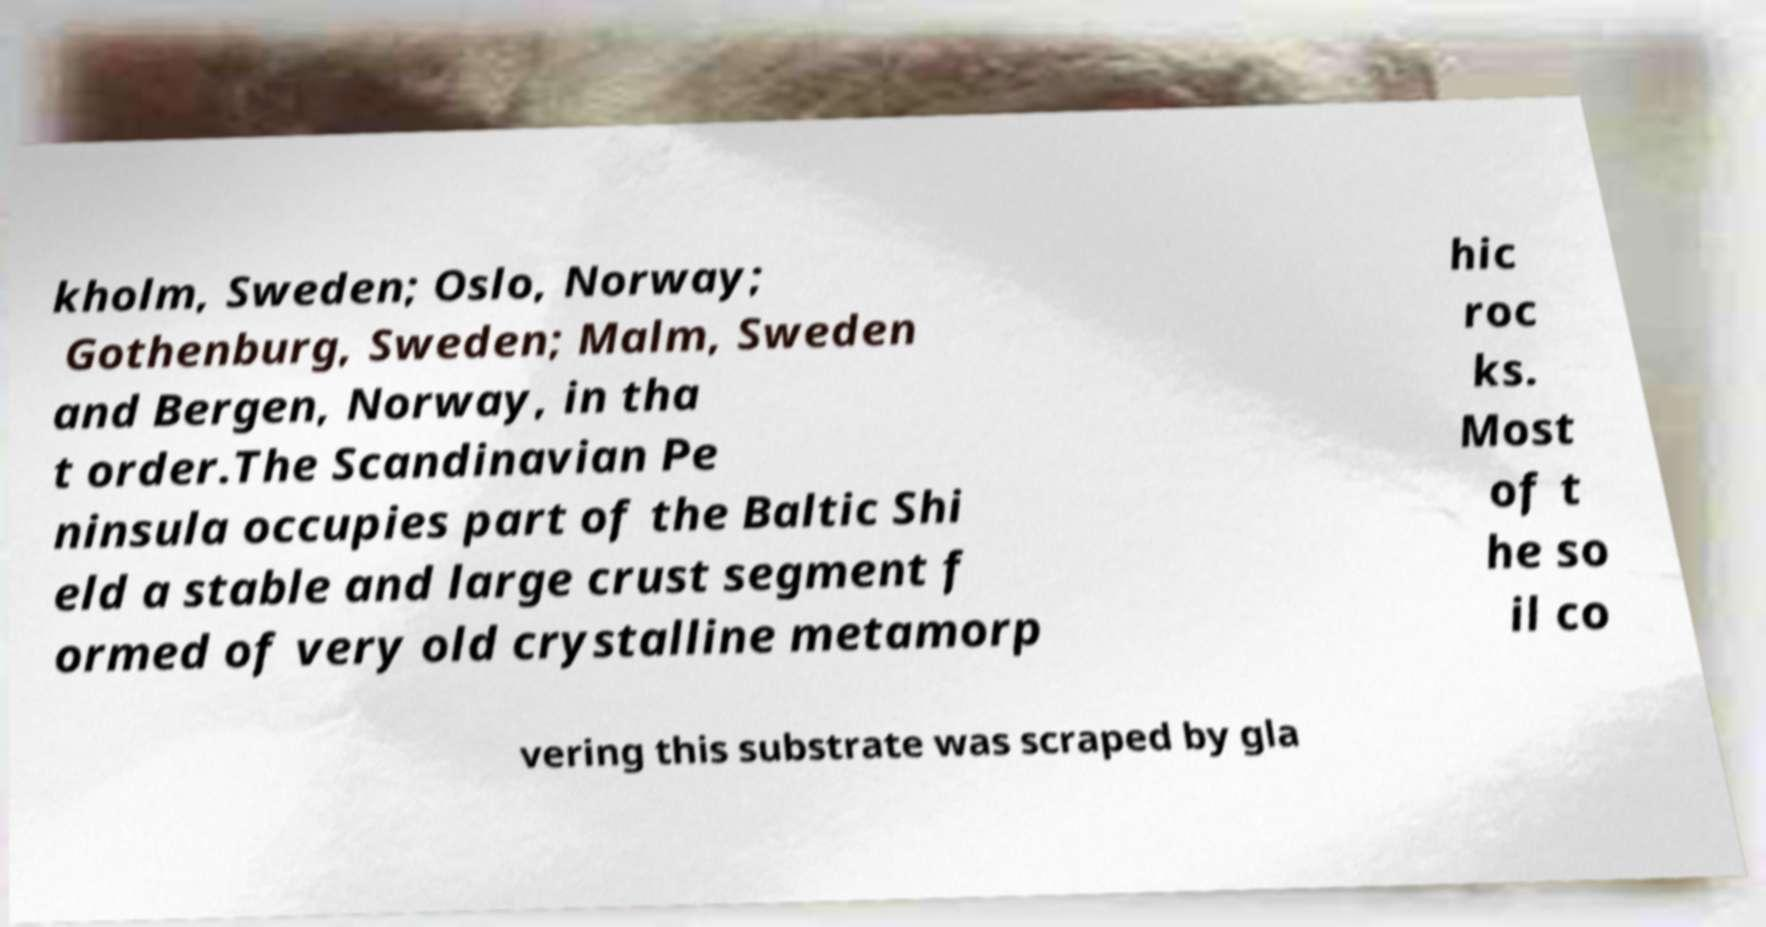Could you assist in decoding the text presented in this image and type it out clearly? kholm, Sweden; Oslo, Norway; Gothenburg, Sweden; Malm, Sweden and Bergen, Norway, in tha t order.The Scandinavian Pe ninsula occupies part of the Baltic Shi eld a stable and large crust segment f ormed of very old crystalline metamorp hic roc ks. Most of t he so il co vering this substrate was scraped by gla 